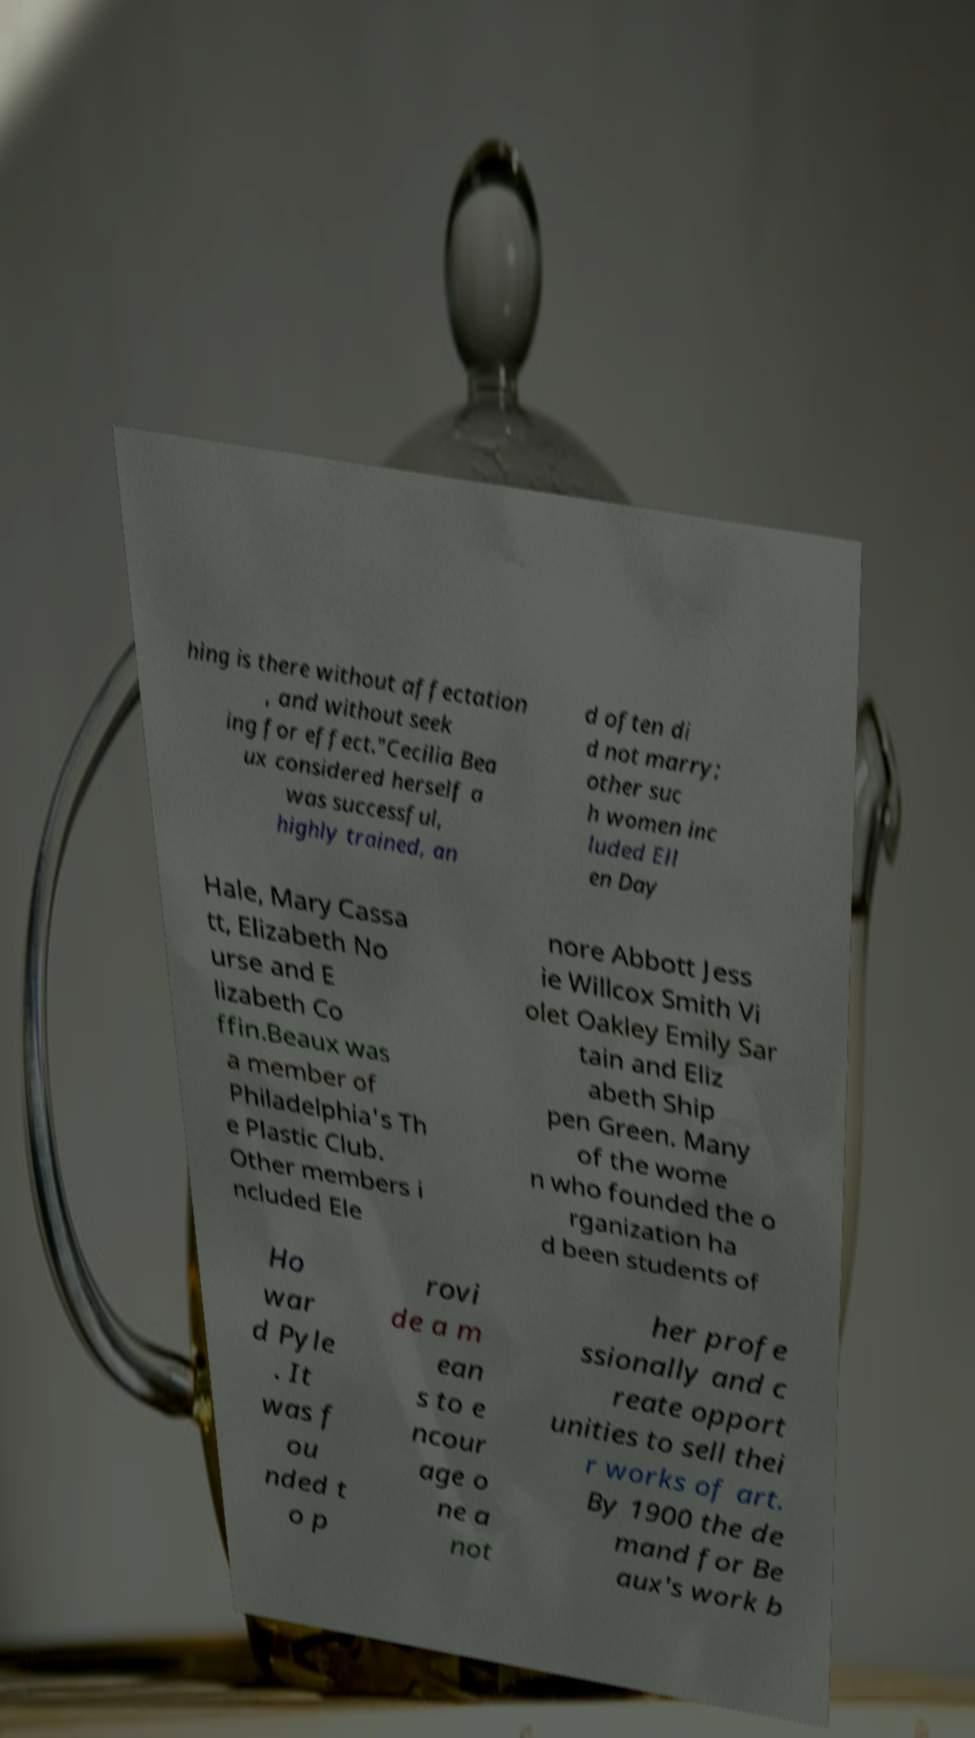Please identify and transcribe the text found in this image. hing is there without affectation , and without seek ing for effect."Cecilia Bea ux considered herself a was successful, highly trained, an d often di d not marry; other suc h women inc luded Ell en Day Hale, Mary Cassa tt, Elizabeth No urse and E lizabeth Co ffin.Beaux was a member of Philadelphia's Th e Plastic Club. Other members i ncluded Ele nore Abbott Jess ie Willcox Smith Vi olet Oakley Emily Sar tain and Eliz abeth Ship pen Green. Many of the wome n who founded the o rganization ha d been students of Ho war d Pyle . It was f ou nded t o p rovi de a m ean s to e ncour age o ne a not her profe ssionally and c reate opport unities to sell thei r works of art. By 1900 the de mand for Be aux's work b 